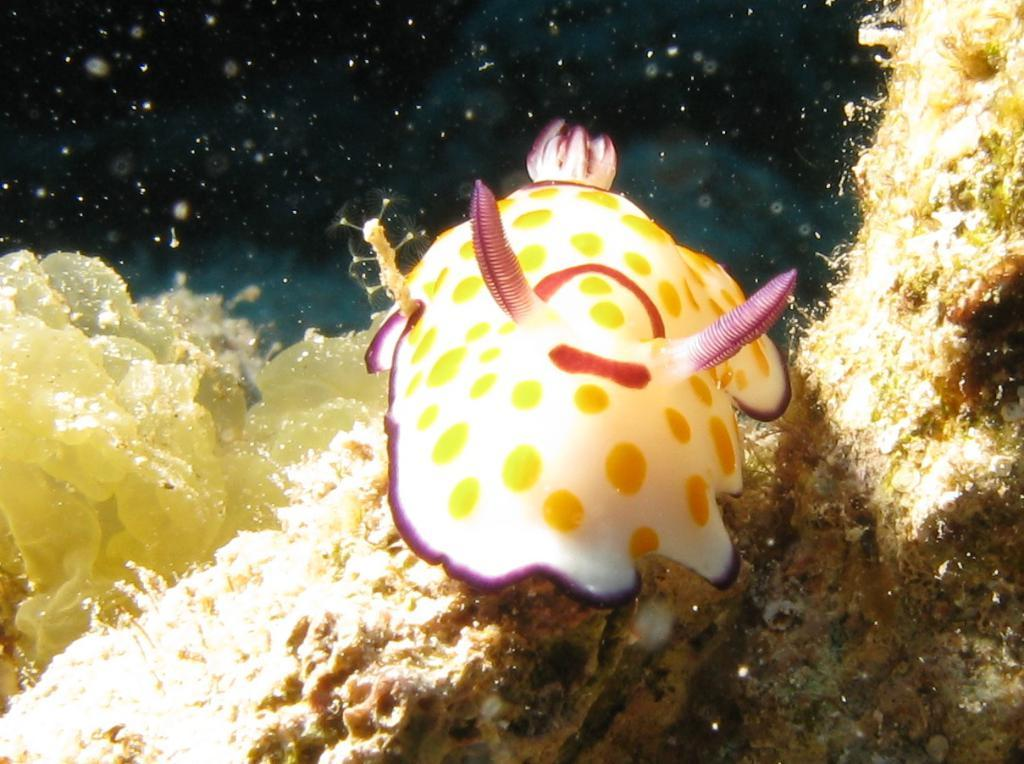What is the primary color of the object in the image? The primary color of the object in the image is white. Are there any additional colors or patterns on the white object? Yes, there are yellow dots on the white object. What type of oil is being used to lubricate the baseball in the image? There is no baseball or oil present in the image; it only features a white object with yellow dots. 